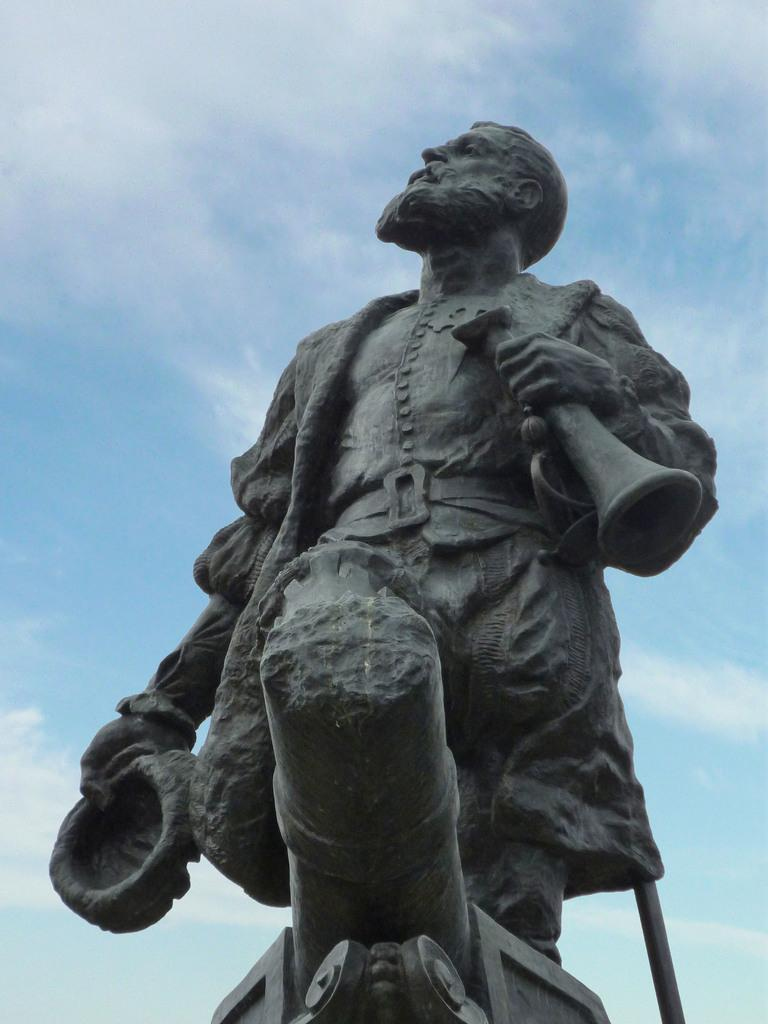What is the main subject in the image? There is a statue in the image. What is visible at the top of the image? The sky is visible at the top of the image. What type of dress is the statue wearing in the image? The statue is not wearing a dress, as it is a statue and not a person. 